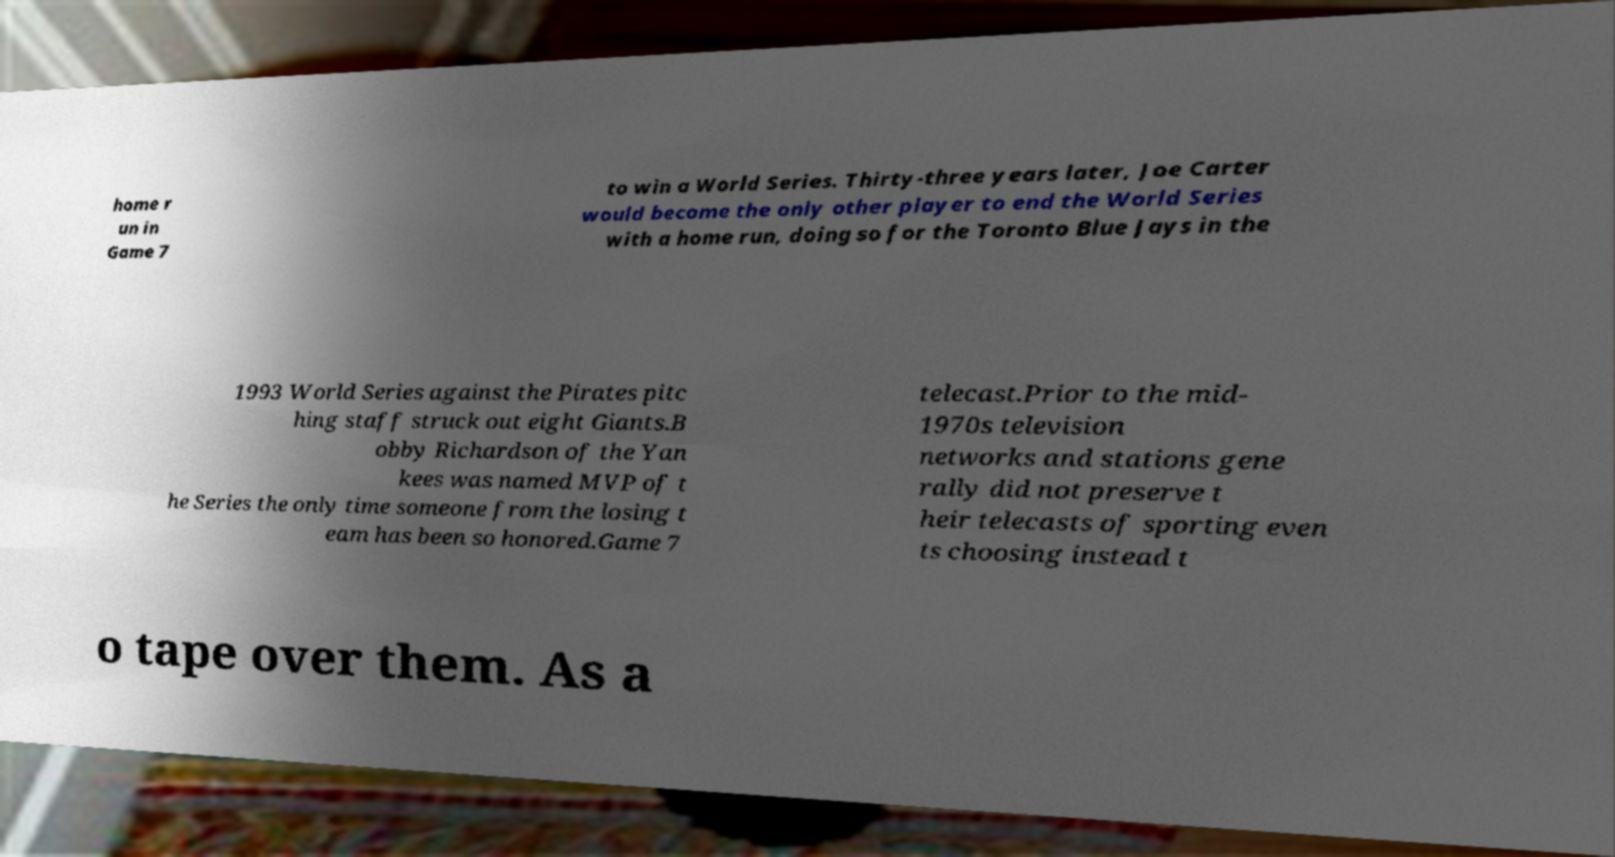I need the written content from this picture converted into text. Can you do that? home r un in Game 7 to win a World Series. Thirty-three years later, Joe Carter would become the only other player to end the World Series with a home run, doing so for the Toronto Blue Jays in the 1993 World Series against the Pirates pitc hing staff struck out eight Giants.B obby Richardson of the Yan kees was named MVP of t he Series the only time someone from the losing t eam has been so honored.Game 7 telecast.Prior to the mid- 1970s television networks and stations gene rally did not preserve t heir telecasts of sporting even ts choosing instead t o tape over them. As a 